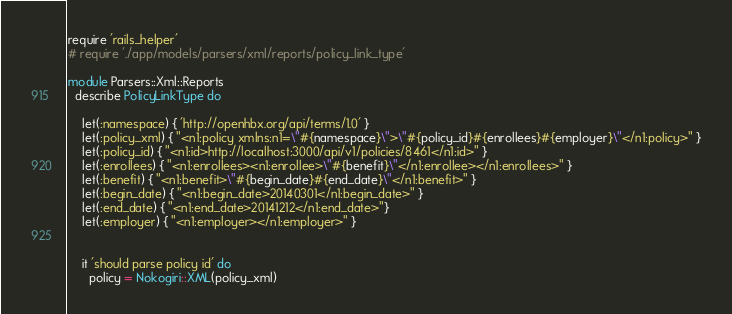Convert code to text. <code><loc_0><loc_0><loc_500><loc_500><_Ruby_>require 'rails_helper'
# require './app/models/parsers/xml/reports/policy_link_type'

module Parsers::Xml::Reports
  describe PolicyLinkType do

    let(:namespace) { 'http://openhbx.org/api/terms/1.0' }
    let(:policy_xml) { "<n1:policy xmlns:n1=\"#{namespace}\">\"#{policy_id}#{enrollees}#{employer}\"</n1:policy>" }
    let(:policy_id) { "<n1:id>http://localhost:3000/api/v1/policies/8461</n1:id>" }
    let(:enrollees) { "<n1:enrollees><n1:enrollee>\"#{benefit}\"</n1:enrollee></n1:enrollees>" }
    let(:benefit) { "<n1:benefit>\"#{begin_date}#{end_date}\"</n1:benefit>" }
    let(:begin_date) { "<n1:begin_date>20140301</n1:begin_date>" }
    let(:end_date) { "<n1:end_date>20141212</n1:end_date>"}
    let(:employer) { "<n1:employer></n1:employer>" }


    it 'should parse policy id' do
      policy = Nokogiri::XML(policy_xml)</code> 